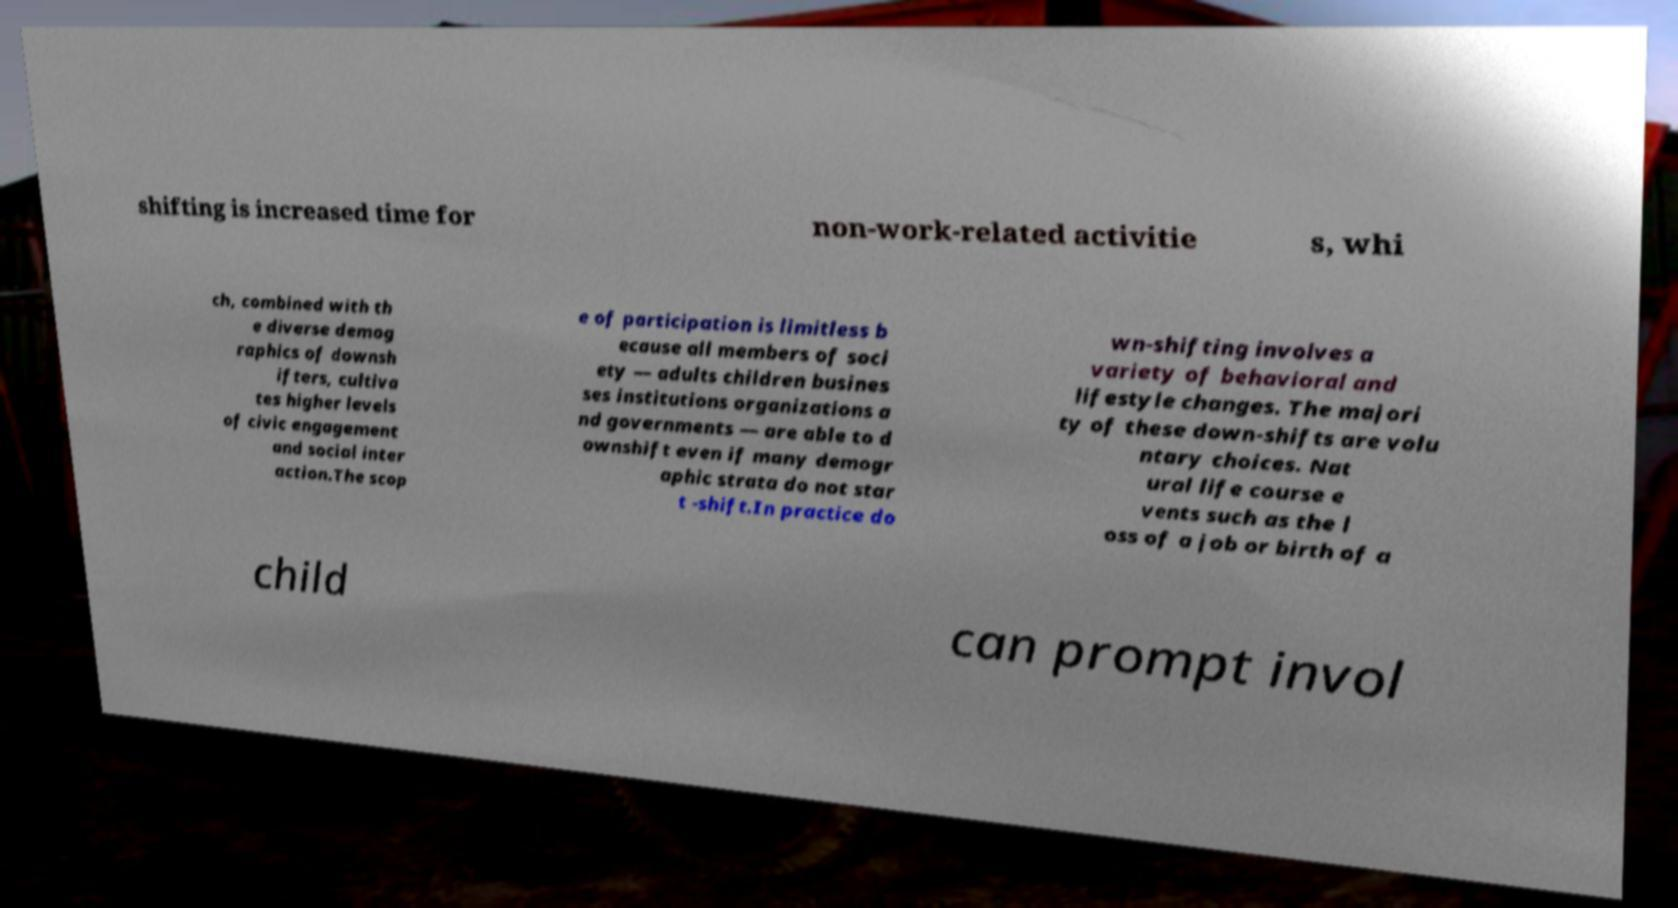Can you accurately transcribe the text from the provided image for me? shifting is increased time for non-work-related activitie s, whi ch, combined with th e diverse demog raphics of downsh ifters, cultiva tes higher levels of civic engagement and social inter action.The scop e of participation is limitless b ecause all members of soci ety — adults children busines ses institutions organizations a nd governments — are able to d ownshift even if many demogr aphic strata do not star t -shift.In practice do wn-shifting involves a variety of behavioral and lifestyle changes. The majori ty of these down-shifts are volu ntary choices. Nat ural life course e vents such as the l oss of a job or birth of a child can prompt invol 